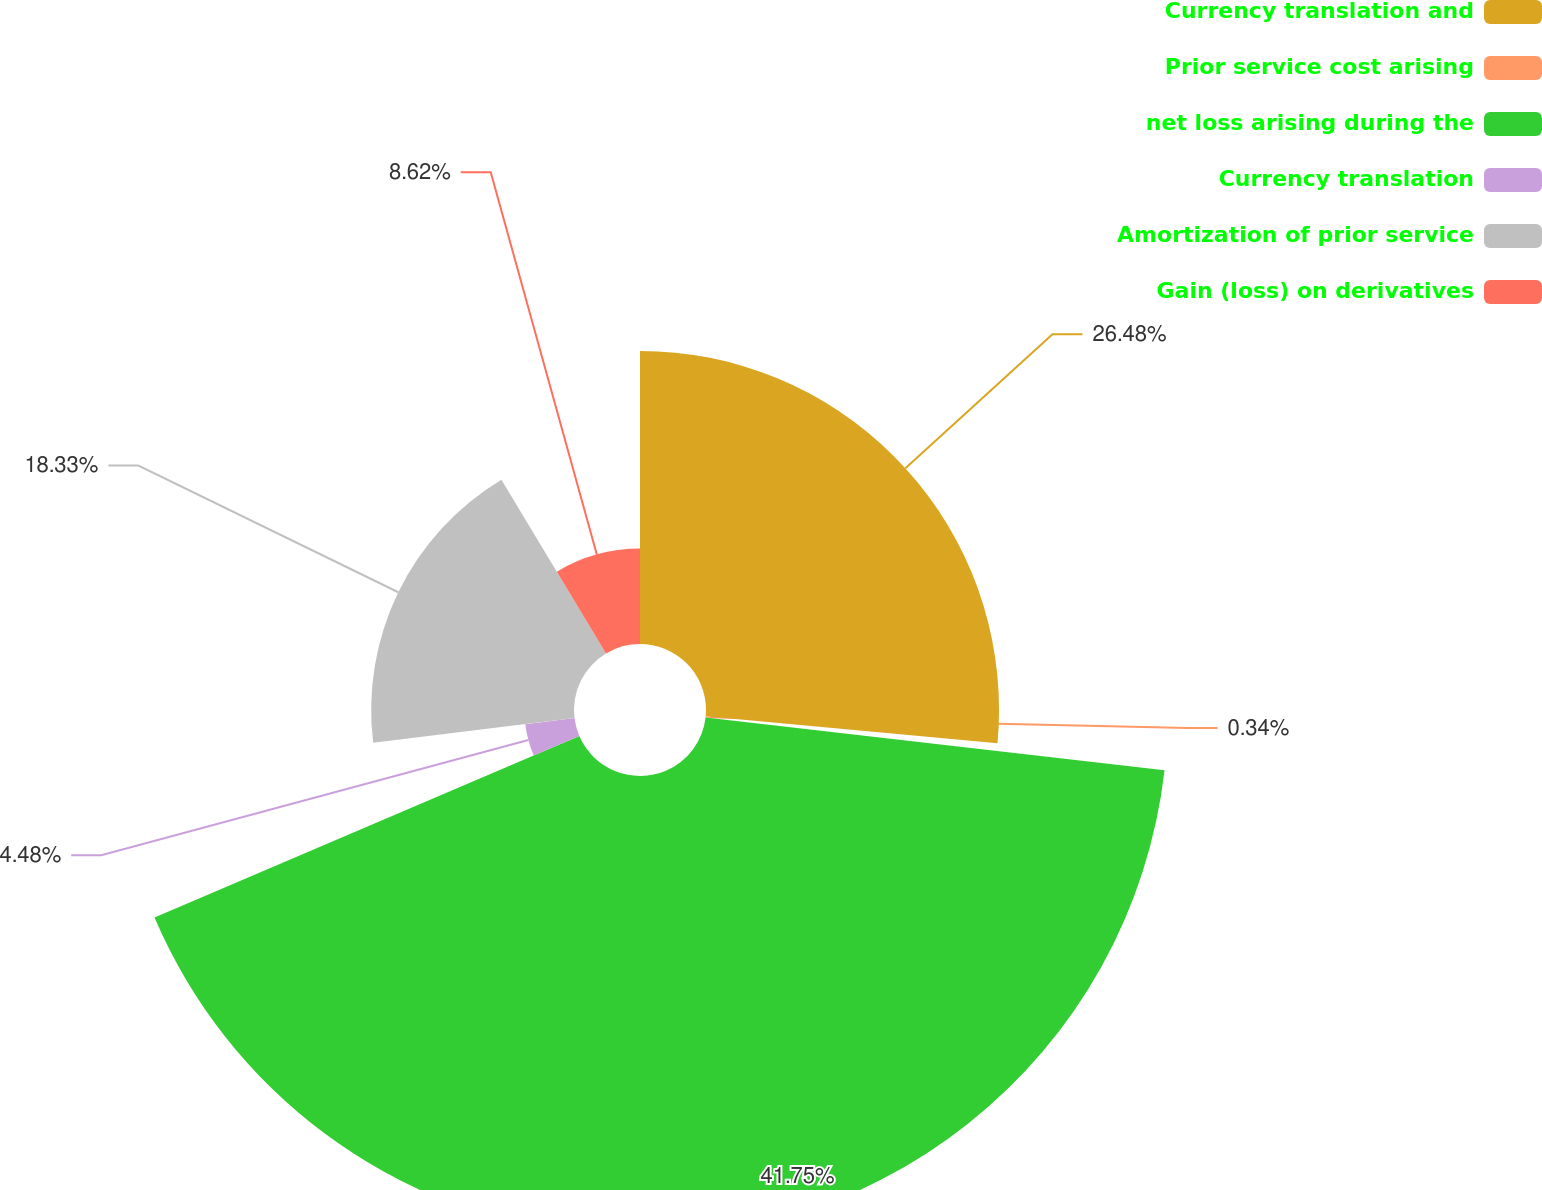<chart> <loc_0><loc_0><loc_500><loc_500><pie_chart><fcel>Currency translation and<fcel>Prior service cost arising<fcel>net loss arising during the<fcel>Currency translation<fcel>Amortization of prior service<fcel>Gain (loss) on derivatives<nl><fcel>26.48%<fcel>0.34%<fcel>41.75%<fcel>4.48%<fcel>18.33%<fcel>8.62%<nl></chart> 